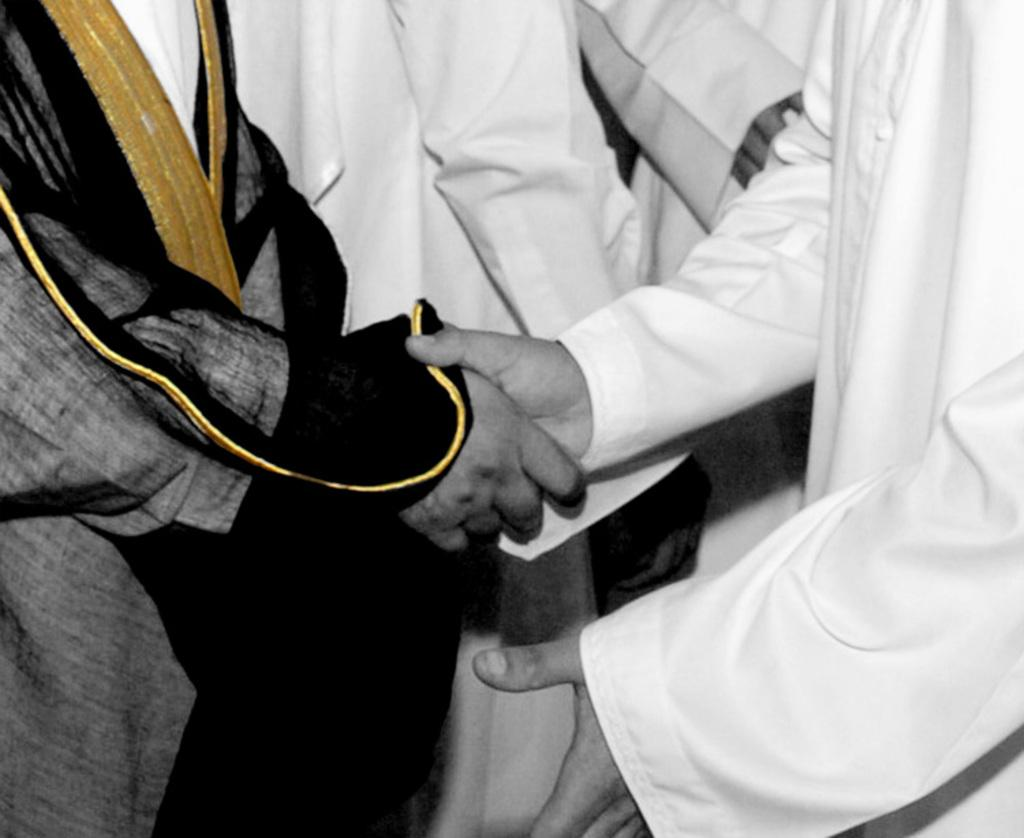How many people are in the image? There are two people in the image. What are the two people doing? The two people are shaking hands. What can be seen in the background of the image? Clothes are visible in the background. Are there any human body parts visible in the image? Yes, human hands are present in the background. What type of powder can be seen falling from the sky in the image? There is no powder falling from the sky in the image. How many pigs are present in the image? There are no pigs present in the image. 